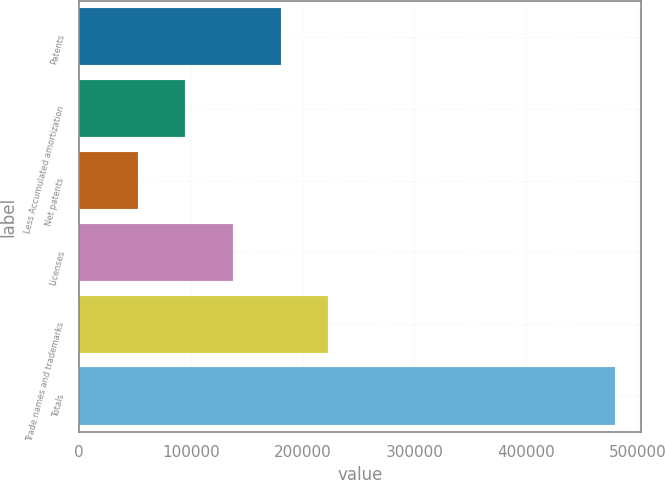<chart> <loc_0><loc_0><loc_500><loc_500><bar_chart><fcel>Patents<fcel>Less Accumulated amortization<fcel>Net patents<fcel>Licenses<fcel>Trade names and trademarks<fcel>Totals<nl><fcel>180389<fcel>95011.6<fcel>52323<fcel>137700<fcel>223077<fcel>479209<nl></chart> 